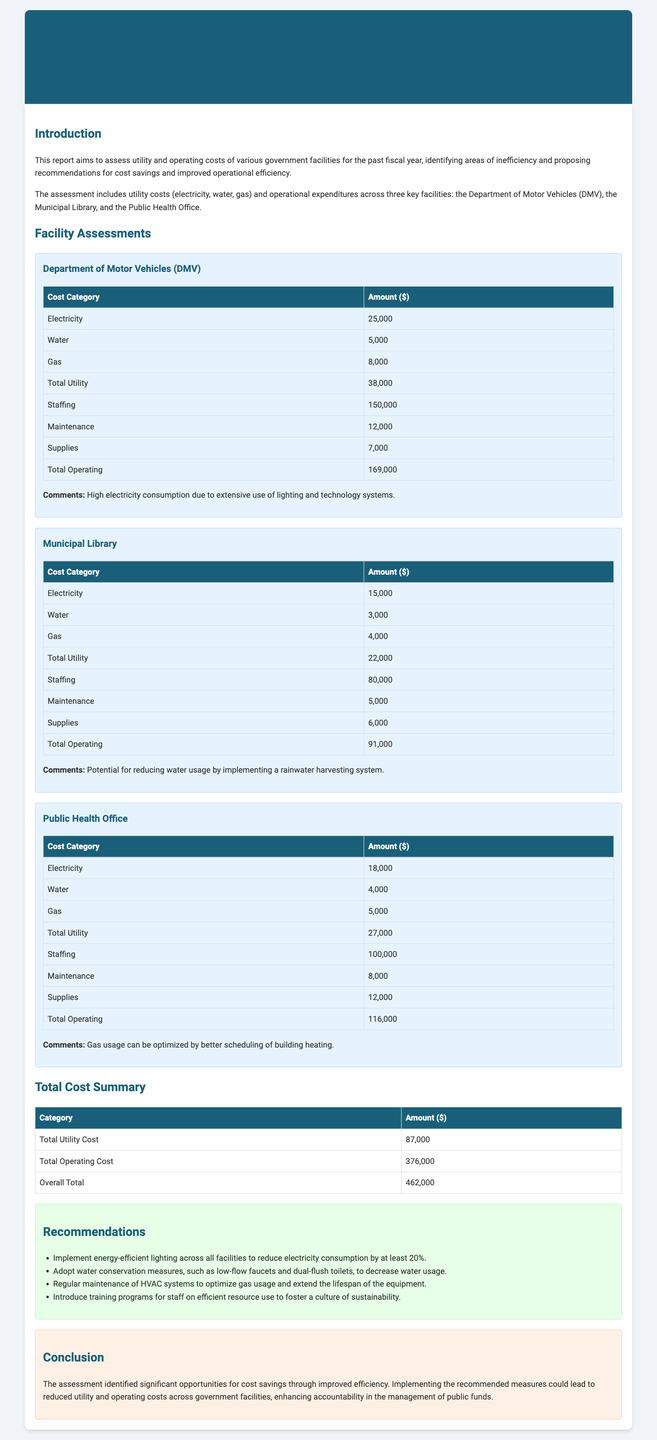What is the total utility cost? The total utility cost is provided in the Total Cost Summary section, which adds up all utility costs across facilities.
Answer: 87,000 What facility has the highest total operating cost? By comparing the total operating costs of each facility, it can be determined which one is the highest. The Department of Motor Vehicles has the highest operating cost at $169,000.
Answer: Department of Motor Vehicles What recommendation is made for water conservation? The recommendations section includes specific measures for water conservation, including low-flow faucets and dual-flush toilets.
Answer: Low-flow faucets and dual-flush toilets What is the total cost for the Public Health Office? The total operating and utility costs for the Public Health Office can be found in the facility assessments, which sums both costs.
Answer: 116,000 How much is spent on maintenance for the Municipal Library? The maintenance cost for the Municipal Library is listed under facility assessments specifically for this facility.
Answer: 5,000 What is a comment made regarding the DMV's electricity usage? The comments section under the DMV facility provides insight into why electricity costs are high, indicating a reason for high consumption.
Answer: High electricity consumption due to extensive use of lighting and technology systems What is the overall total cost across all facilities? The overall total cost is calculated in the Total Cost Summary by adding total utility and operating costs.
Answer: 462,000 Which utility has the highest expenditure at the DMV? The table for the DMV shows how much is allocated to different utility categories, following this will reveal the highest expenditure.
Answer: Electricity What is a suggested measure to reduce gas usage? The recommendations provide specific suggestions for improving efficiency in gas usage and specific steps that can be taken.
Answer: Regular maintenance of HVAC systems 